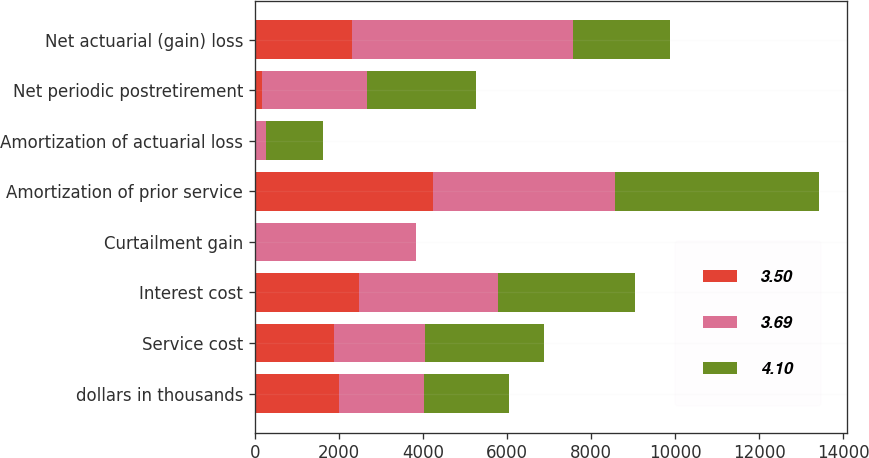<chart> <loc_0><loc_0><loc_500><loc_500><stacked_bar_chart><ecel><fcel>dollars in thousands<fcel>Service cost<fcel>Interest cost<fcel>Curtailment gain<fcel>Amortization of prior service<fcel>Amortization of actuarial loss<fcel>Net periodic postretirement<fcel>Net actuarial (gain) loss<nl><fcel>3.5<fcel>2015<fcel>1894<fcel>2485<fcel>0<fcel>4232<fcel>37<fcel>184<fcel>2315.5<nl><fcel>3.69<fcel>2014<fcel>2146<fcel>3297<fcel>3832<fcel>4327<fcel>227<fcel>2489<fcel>5256<nl><fcel>4.1<fcel>2013<fcel>2830<fcel>3260<fcel>0<fcel>4863<fcel>1372<fcel>2599<fcel>2315.5<nl></chart> 